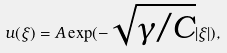<formula> <loc_0><loc_0><loc_500><loc_500>u ( \xi ) = A \exp ( - \sqrt { \gamma / C } | \xi | ) ,</formula> 